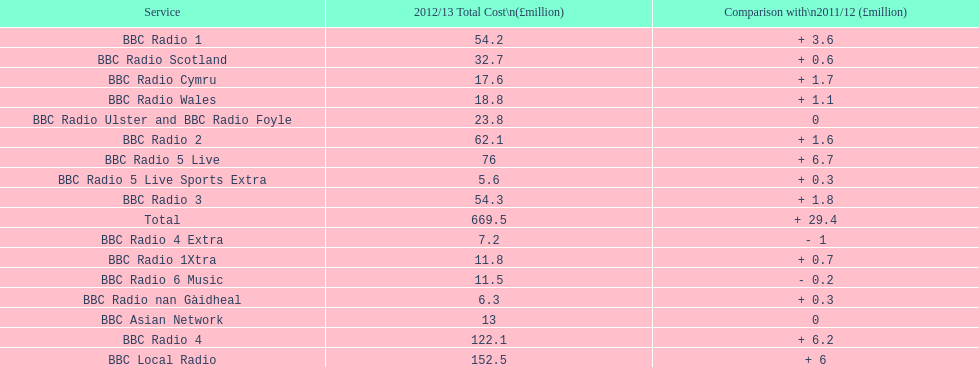Which bbc station had cost the most to run in 2012/13? BBC Local Radio. 